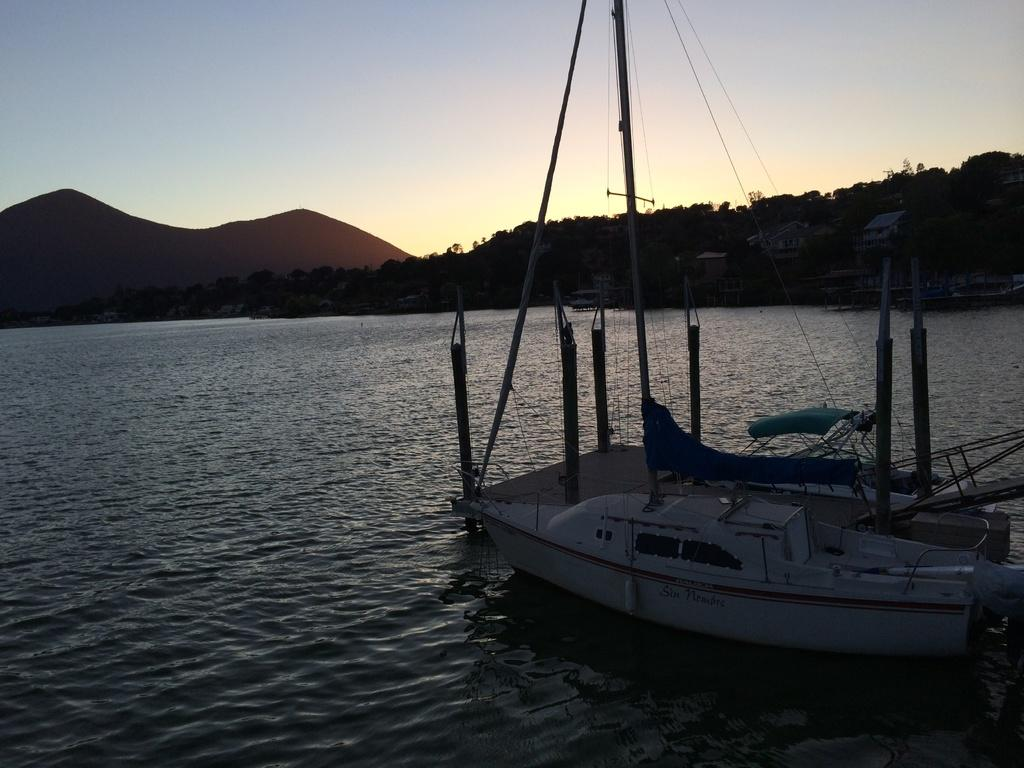What type of vehicle is in the image? There is a white boat in the image. What is at the bottom of the image? There is water at the bottom of the image. What can be seen in the background of the image? There are plants and mountains in the background of the image. What is visible at the top of the image? The sky is visible at the top of the image. What type of hospital can be seen in the image? There is no hospital present in the image; it features a white boat on water with plants, mountains, and sky in the background. How do the plants look in the image? The plants are not described as looking a certain way in the image; they are simply present in the background. 